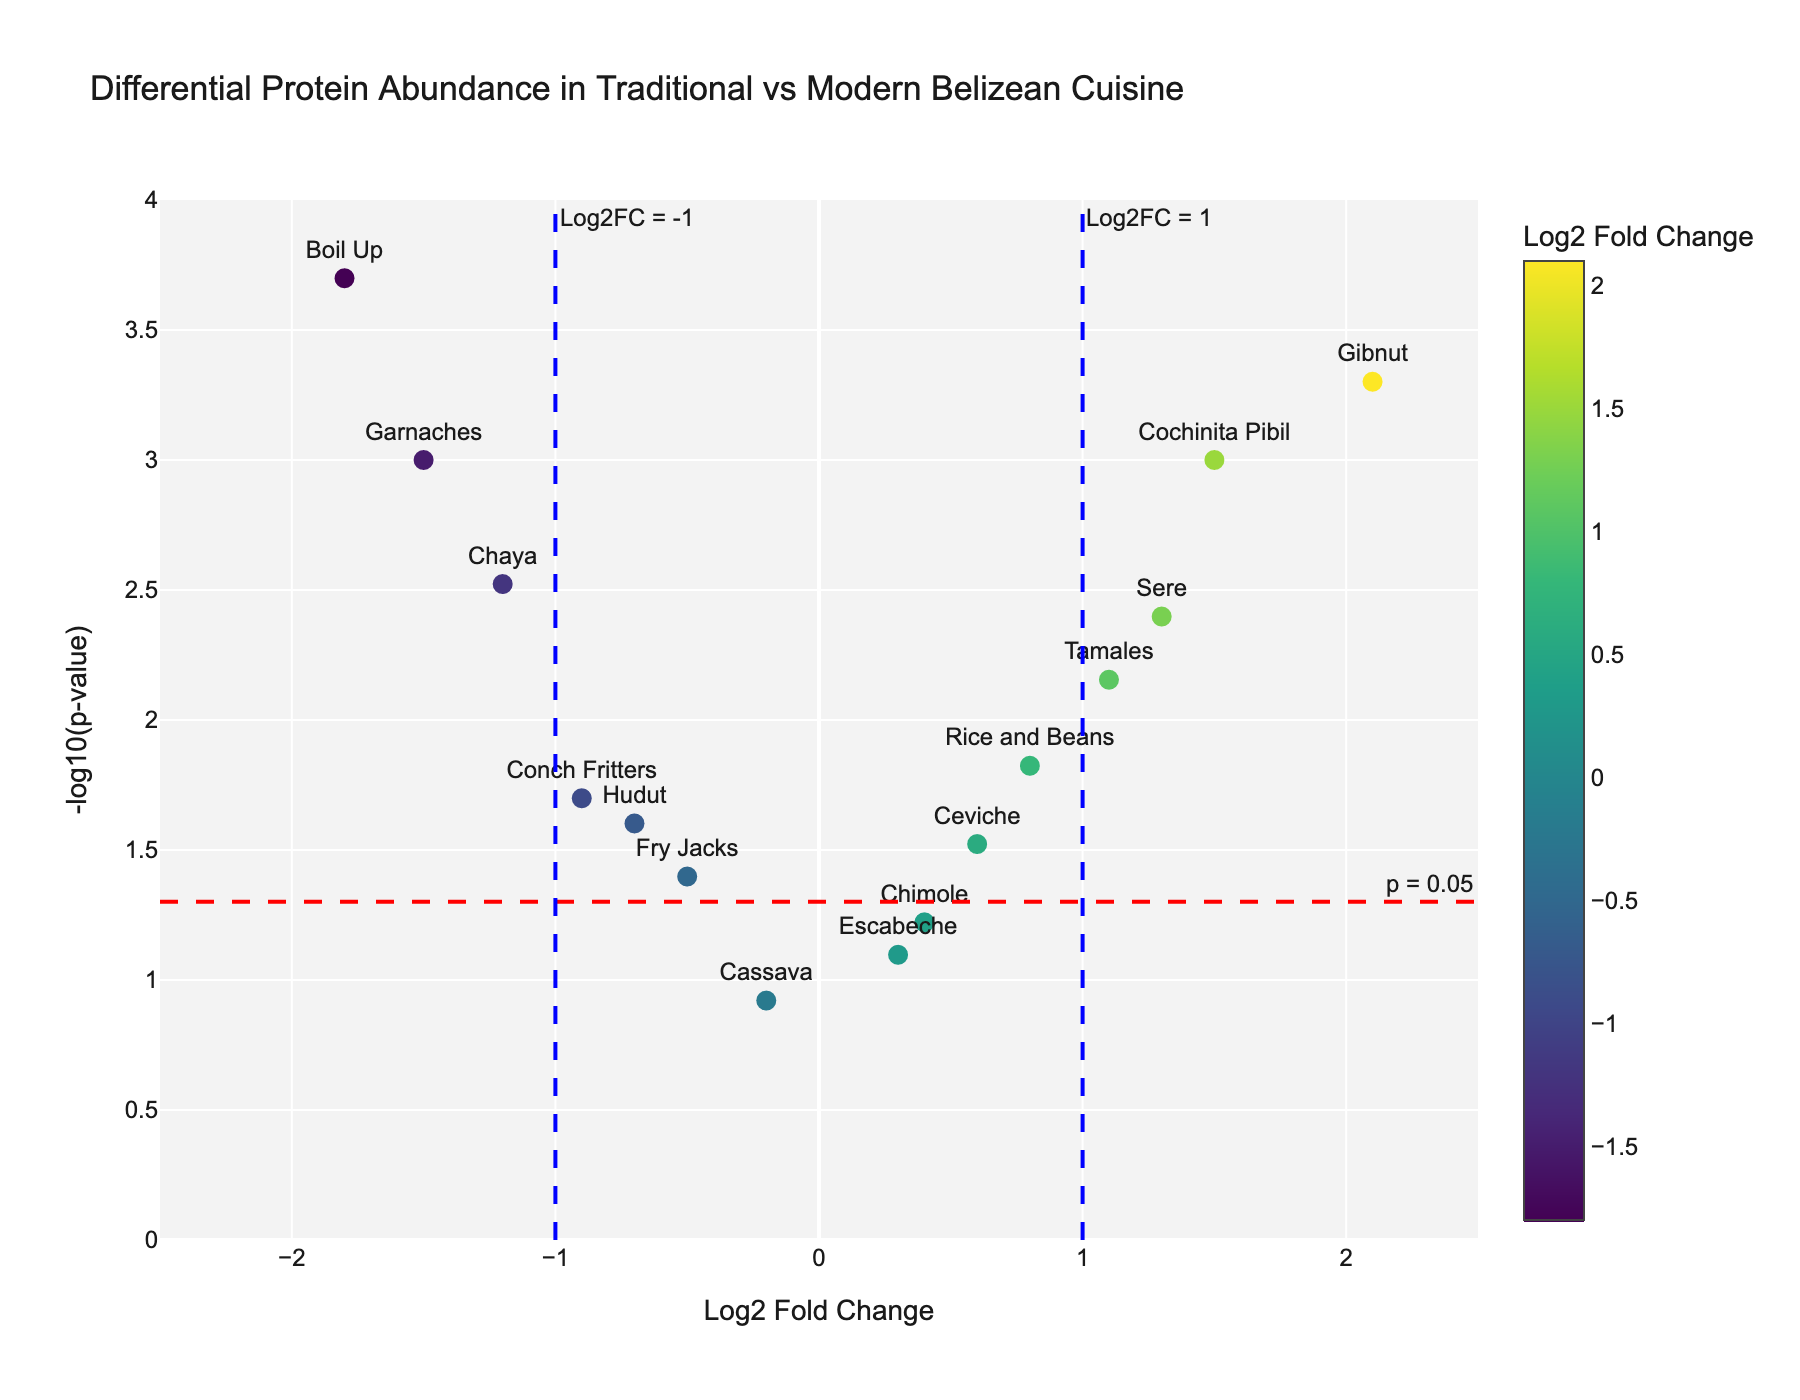What's the title of the plot? The title of the plot is written at the top of the figure in a large, bold font, describing the main purpose of the visualization.
Answer: Differential Protein Abundance in Traditional vs Modern Belizean Cuisine What does the x-axis represent? The x-axis is labeled at the bottom of the plot and indicates the Log2 Fold Change of protein abundance between traditional and modern Belizean cuisines.
Answer: Log2 Fold Change Which protein has the highest Log2 Fold Change? By looking at the data points on the x-axis, the protein with the farthest point to the right has the highest Log2 Fold Change.
Answer: Gibnut How many proteins have a p-value less than 0.05? Proteins with a p-value less than 0.05 appear above the horizontal red dashed line on the plot. Count these points.
Answer: 10 What can be inferred about proteins located in the upper left quadrant? Proteins in the upper left quadrant have a negative Log2 Fold Change and a significant (low) p-value, indicating lower abundance in modern cuisine compared to traditional cuisine with statistical significance.
Answer: Less abundant in modern cuisine, statistically significant Which proteins lie within the fold change range of Log2FC = -1 and Log2FC = 1? Look at the data points between the vertical blue dashed lines at x = -1 and x = 1 to find which proteins fall within this range.
Answer: Rice and Beans, Escabeche, Chimole, Ceviche, Cassava What is the most statistically significant protein and what is its p-value? The most statistically significant protein has the highest y-axis value which represents the -log10(p-value). Check the data point at the highest y-axis position to determine this protein and its corresponding p-value.
Answer: Boil Up, 0.0002 What is the significance threshold for the p-value indicated in the plot? The plot includes a horizontal dashed red line annotating the significance threshold for p-value, typically marked for reference.
Answer: 0.05 Which proteins show a Log2 Fold Change greater than 1? Proteins with a Log2 Fold Change greater than 1 will be located to the right of the vertical blue dashed line at x = 1. Identify these points.
Answer: Cochinita Pibil, Tamales, Sere, Gibnut 